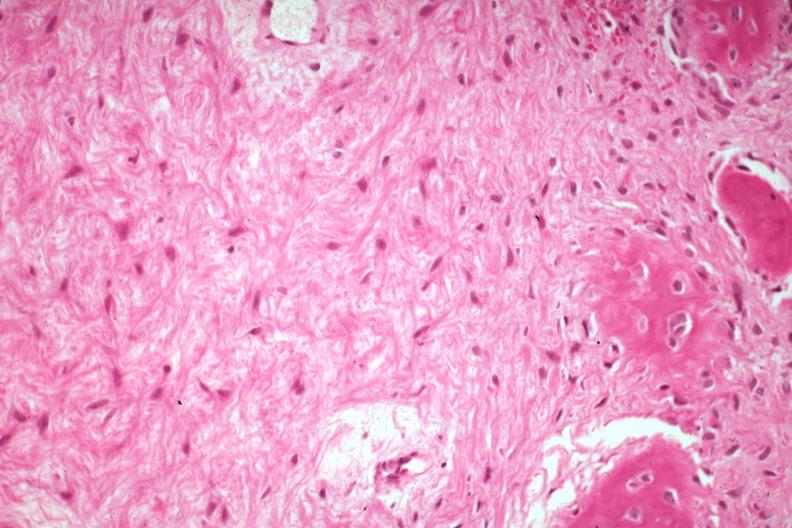what is present?
Answer the question using a single word or phrase. Joints 